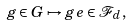Convert formula to latex. <formula><loc_0><loc_0><loc_500><loc_500>g \in G \mapsto g \, e \in \mathcal { F } _ { d } ,</formula> 